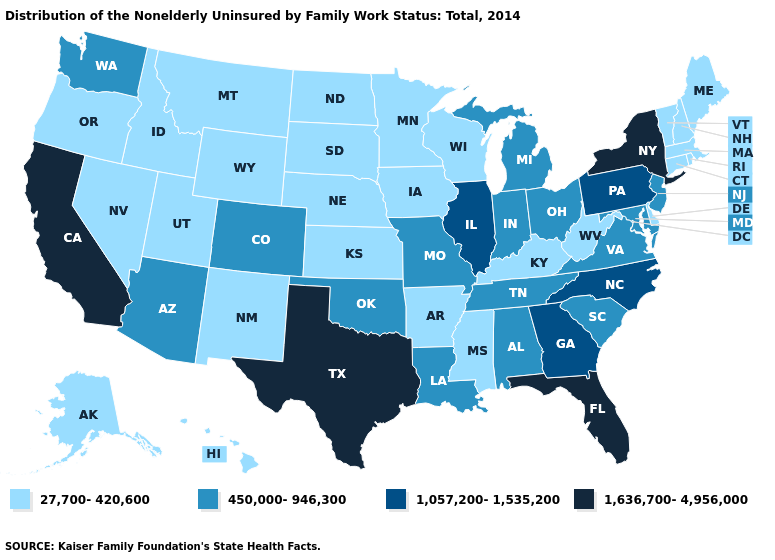Among the states that border Iowa , which have the lowest value?
Keep it brief. Minnesota, Nebraska, South Dakota, Wisconsin. Name the states that have a value in the range 27,700-420,600?
Be succinct. Alaska, Arkansas, Connecticut, Delaware, Hawaii, Idaho, Iowa, Kansas, Kentucky, Maine, Massachusetts, Minnesota, Mississippi, Montana, Nebraska, Nevada, New Hampshire, New Mexico, North Dakota, Oregon, Rhode Island, South Dakota, Utah, Vermont, West Virginia, Wisconsin, Wyoming. Does New Hampshire have a higher value than Colorado?
Keep it brief. No. What is the value of South Dakota?
Quick response, please. 27,700-420,600. Which states hav the highest value in the Northeast?
Give a very brief answer. New York. What is the value of New Mexico?
Keep it brief. 27,700-420,600. What is the value of Vermont?
Short answer required. 27,700-420,600. Name the states that have a value in the range 1,636,700-4,956,000?
Keep it brief. California, Florida, New York, Texas. Does Maine have a higher value than Arizona?
Give a very brief answer. No. Does Kentucky have the highest value in the South?
Write a very short answer. No. What is the value of California?
Be succinct. 1,636,700-4,956,000. Does New Hampshire have the lowest value in the USA?
Concise answer only. Yes. Name the states that have a value in the range 450,000-946,300?
Give a very brief answer. Alabama, Arizona, Colorado, Indiana, Louisiana, Maryland, Michigan, Missouri, New Jersey, Ohio, Oklahoma, South Carolina, Tennessee, Virginia, Washington. How many symbols are there in the legend?
Give a very brief answer. 4. What is the highest value in the Northeast ?
Concise answer only. 1,636,700-4,956,000. 